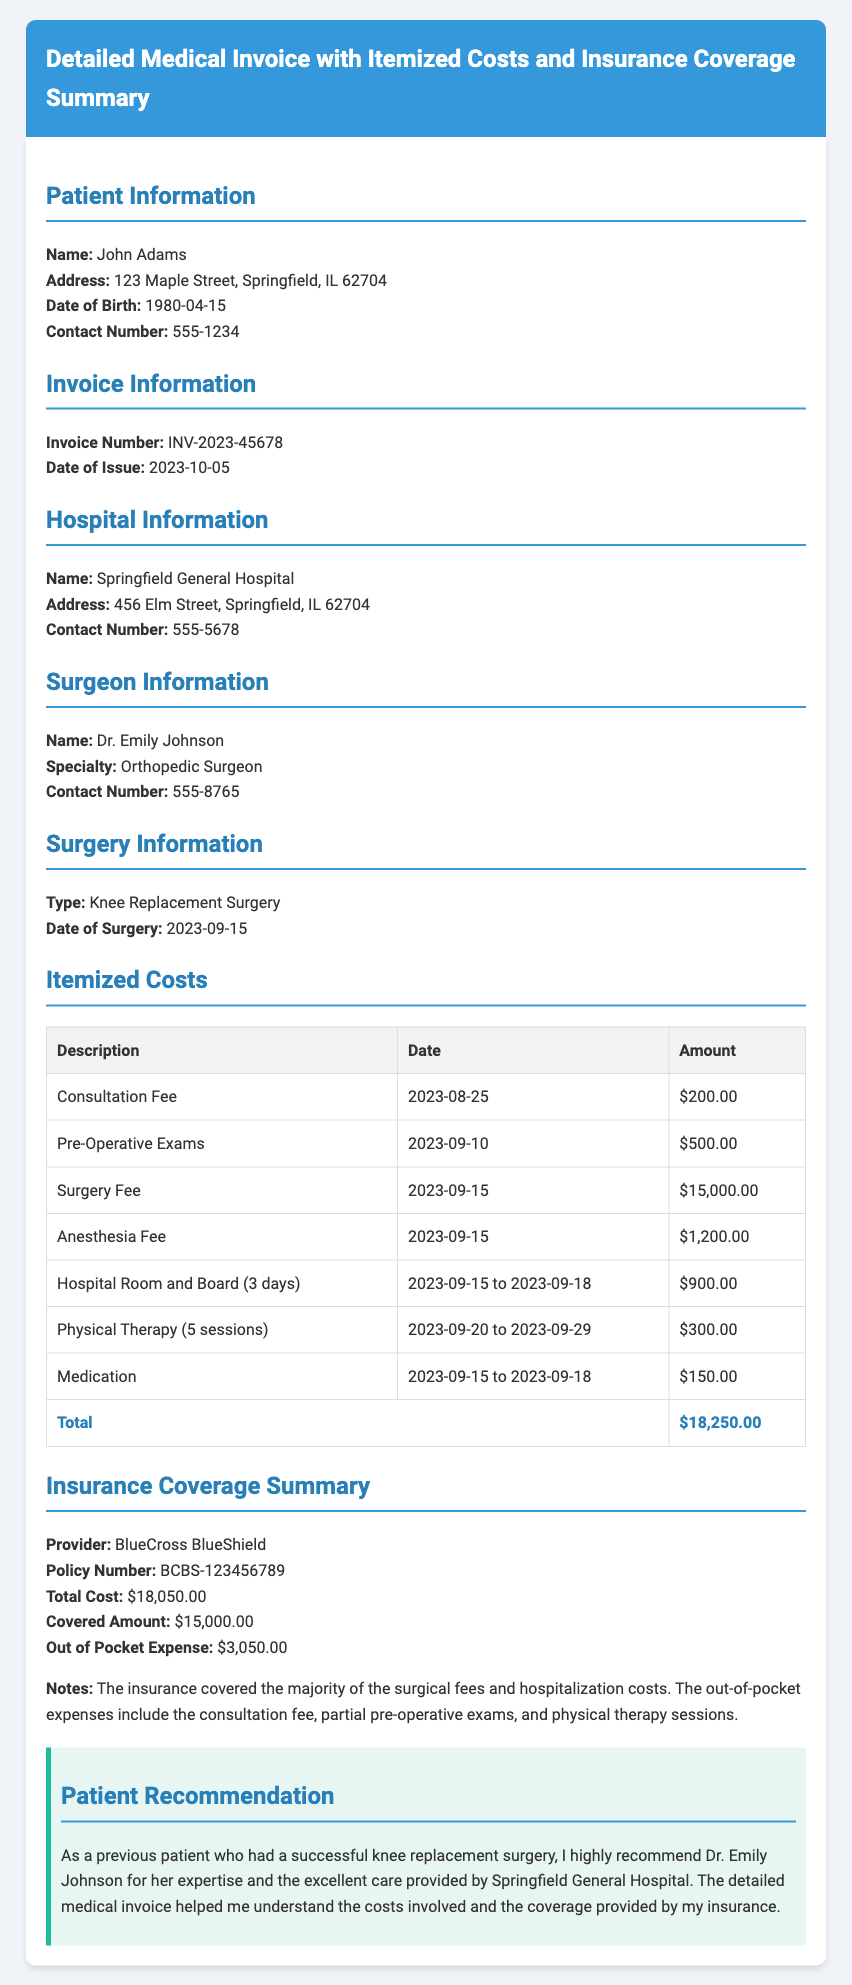What is the patient's name? The patient's name is mentioned at the top of the document under patient information.
Answer: John Adams Who is the surgeon? The document lists the surgeon's information, including their name and specialty.
Answer: Dr. Emily Johnson What is the total amount billed? The total amount is found in the itemized costs section under the "Total" row.
Answer: $18,250.00 What is the date of the surgery? The date of surgery is specified in the surgery information section.
Answer: 2023-09-15 What amount did the insurance cover? The insurance coverage summary specifies the covered amount provided by the insurance.
Answer: $15,000.00 What is the out-of-pocket expense for the patient? The out-of-pocket expense is stated in the insurance coverage summary.
Answer: $3,050.00 How many days was the patient in the hospital? The duration of the hospital stay is indicated in the itemized costs section for room and board.
Answer: 3 days What type of surgery did the patient undergo? The type of surgery is noted in the surgery information section.
Answer: Knee Replacement Surgery What was included in the out-of-pocket expenses? The notes section explains what expenses the patient needed to cover out of pocket.
Answer: Consultation fee, partial pre-operative exams, physical therapy sessions 